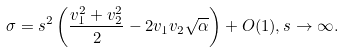<formula> <loc_0><loc_0><loc_500><loc_500>\sigma = s ^ { 2 } \left ( \frac { v _ { 1 } ^ { 2 } + v _ { 2 } ^ { 2 } } { 2 } - 2 v _ { 1 } v _ { 2 } \sqrt { \alpha } \right ) + O ( 1 ) , s \to \infty .</formula> 